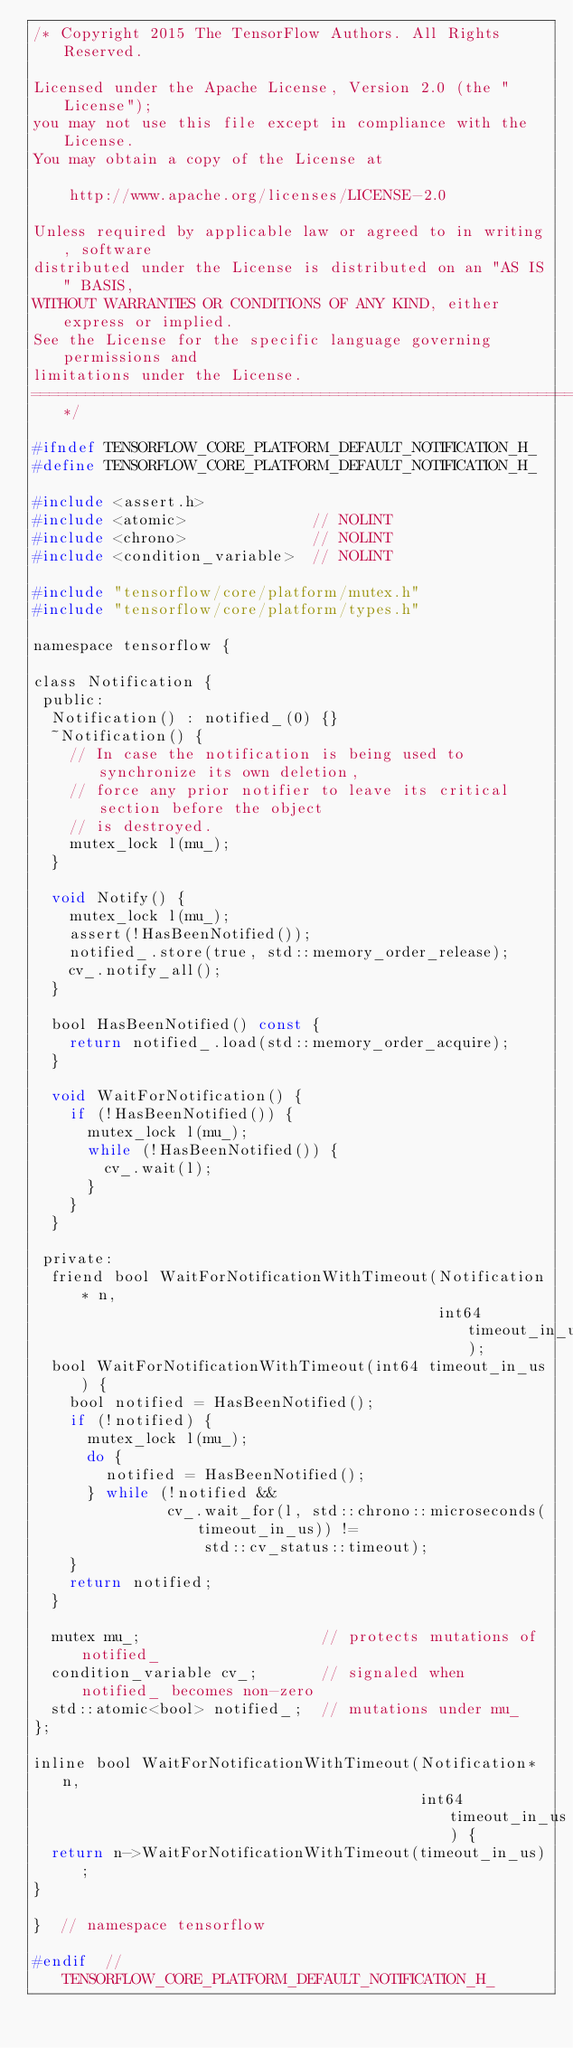Convert code to text. <code><loc_0><loc_0><loc_500><loc_500><_C_>/* Copyright 2015 The TensorFlow Authors. All Rights Reserved.

Licensed under the Apache License, Version 2.0 (the "License");
you may not use this file except in compliance with the License.
You may obtain a copy of the License at

    http://www.apache.org/licenses/LICENSE-2.0

Unless required by applicable law or agreed to in writing, software
distributed under the License is distributed on an "AS IS" BASIS,
WITHOUT WARRANTIES OR CONDITIONS OF ANY KIND, either express or implied.
See the License for the specific language governing permissions and
limitations under the License.
==============================================================================*/

#ifndef TENSORFLOW_CORE_PLATFORM_DEFAULT_NOTIFICATION_H_
#define TENSORFLOW_CORE_PLATFORM_DEFAULT_NOTIFICATION_H_

#include <assert.h>
#include <atomic>              // NOLINT
#include <chrono>              // NOLINT
#include <condition_variable>  // NOLINT

#include "tensorflow/core/platform/mutex.h"
#include "tensorflow/core/platform/types.h"

namespace tensorflow {

class Notification {
 public:
  Notification() : notified_(0) {}
  ~Notification() {
    // In case the notification is being used to synchronize its own deletion,
    // force any prior notifier to leave its critical section before the object
    // is destroyed.
    mutex_lock l(mu_);
  }

  void Notify() {
    mutex_lock l(mu_);
    assert(!HasBeenNotified());
    notified_.store(true, std::memory_order_release);
    cv_.notify_all();
  }

  bool HasBeenNotified() const {
    return notified_.load(std::memory_order_acquire);
  }

  void WaitForNotification() {
    if (!HasBeenNotified()) {
      mutex_lock l(mu_);
      while (!HasBeenNotified()) {
        cv_.wait(l);
      }
    }
  }

 private:
  friend bool WaitForNotificationWithTimeout(Notification* n,
                                             int64 timeout_in_us);
  bool WaitForNotificationWithTimeout(int64 timeout_in_us) {
    bool notified = HasBeenNotified();
    if (!notified) {
      mutex_lock l(mu_);
      do {
        notified = HasBeenNotified();
      } while (!notified &&
               cv_.wait_for(l, std::chrono::microseconds(timeout_in_us)) !=
                   std::cv_status::timeout);
    }
    return notified;
  }

  mutex mu_;                    // protects mutations of notified_
  condition_variable cv_;       // signaled when notified_ becomes non-zero
  std::atomic<bool> notified_;  // mutations under mu_
};

inline bool WaitForNotificationWithTimeout(Notification* n,
                                           int64 timeout_in_us) {
  return n->WaitForNotificationWithTimeout(timeout_in_us);
}

}  // namespace tensorflow

#endif  // TENSORFLOW_CORE_PLATFORM_DEFAULT_NOTIFICATION_H_
</code> 